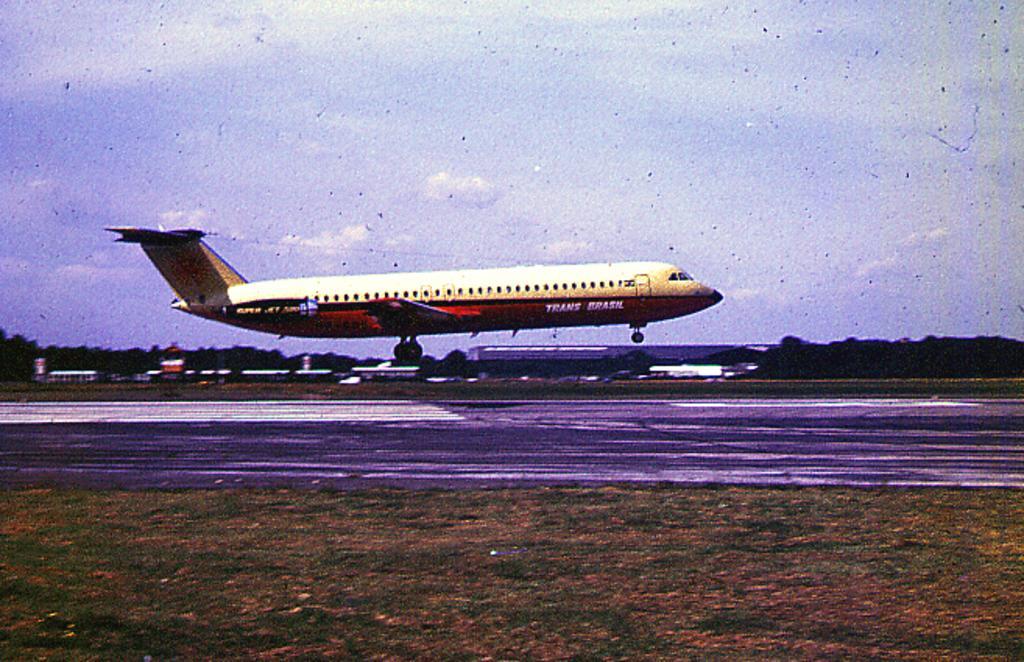Describe this image in one or two sentences. In this picture I can see there is an airplane and it has wings and windows, there is grass on the floor, a runway and there are trees and a building in the backdrop and the sky is clear. 